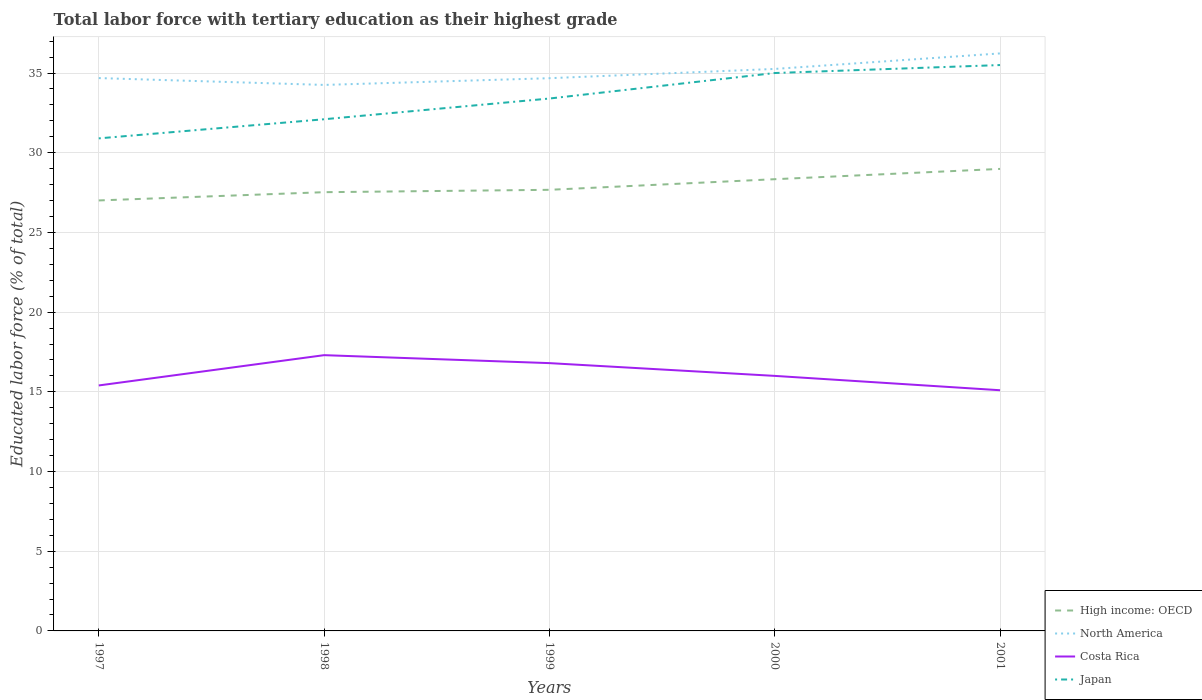Is the number of lines equal to the number of legend labels?
Your answer should be very brief. Yes. Across all years, what is the maximum percentage of male labor force with tertiary education in Costa Rica?
Ensure brevity in your answer.  15.1. What is the total percentage of male labor force with tertiary education in North America in the graph?
Your response must be concise. -1.55. What is the difference between the highest and the second highest percentage of male labor force with tertiary education in High income: OECD?
Give a very brief answer. 1.98. What is the difference between the highest and the lowest percentage of male labor force with tertiary education in High income: OECD?
Provide a short and direct response. 2. Does the graph contain grids?
Keep it short and to the point. Yes. Where does the legend appear in the graph?
Make the answer very short. Bottom right. How are the legend labels stacked?
Your answer should be very brief. Vertical. What is the title of the graph?
Your answer should be compact. Total labor force with tertiary education as their highest grade. What is the label or title of the Y-axis?
Provide a succinct answer. Educated labor force (% of total). What is the Educated labor force (% of total) in High income: OECD in 1997?
Keep it short and to the point. 27.01. What is the Educated labor force (% of total) in North America in 1997?
Keep it short and to the point. 34.68. What is the Educated labor force (% of total) of Costa Rica in 1997?
Provide a short and direct response. 15.4. What is the Educated labor force (% of total) of Japan in 1997?
Offer a very short reply. 30.9. What is the Educated labor force (% of total) in High income: OECD in 1998?
Give a very brief answer. 27.52. What is the Educated labor force (% of total) of North America in 1998?
Give a very brief answer. 34.25. What is the Educated labor force (% of total) of Costa Rica in 1998?
Offer a terse response. 17.3. What is the Educated labor force (% of total) in Japan in 1998?
Make the answer very short. 32.1. What is the Educated labor force (% of total) in High income: OECD in 1999?
Your response must be concise. 27.67. What is the Educated labor force (% of total) of North America in 1999?
Give a very brief answer. 34.68. What is the Educated labor force (% of total) in Costa Rica in 1999?
Keep it short and to the point. 16.8. What is the Educated labor force (% of total) of Japan in 1999?
Your response must be concise. 33.4. What is the Educated labor force (% of total) in High income: OECD in 2000?
Provide a short and direct response. 28.34. What is the Educated labor force (% of total) in North America in 2000?
Ensure brevity in your answer.  35.26. What is the Educated labor force (% of total) in Costa Rica in 2000?
Provide a succinct answer. 16. What is the Educated labor force (% of total) in High income: OECD in 2001?
Provide a short and direct response. 28.98. What is the Educated labor force (% of total) in North America in 2001?
Keep it short and to the point. 36.23. What is the Educated labor force (% of total) in Costa Rica in 2001?
Your response must be concise. 15.1. What is the Educated labor force (% of total) of Japan in 2001?
Provide a succinct answer. 35.5. Across all years, what is the maximum Educated labor force (% of total) in High income: OECD?
Make the answer very short. 28.98. Across all years, what is the maximum Educated labor force (% of total) in North America?
Offer a very short reply. 36.23. Across all years, what is the maximum Educated labor force (% of total) in Costa Rica?
Provide a short and direct response. 17.3. Across all years, what is the maximum Educated labor force (% of total) of Japan?
Provide a short and direct response. 35.5. Across all years, what is the minimum Educated labor force (% of total) in High income: OECD?
Keep it short and to the point. 27.01. Across all years, what is the minimum Educated labor force (% of total) of North America?
Ensure brevity in your answer.  34.25. Across all years, what is the minimum Educated labor force (% of total) in Costa Rica?
Ensure brevity in your answer.  15.1. Across all years, what is the minimum Educated labor force (% of total) of Japan?
Ensure brevity in your answer.  30.9. What is the total Educated labor force (% of total) of High income: OECD in the graph?
Make the answer very short. 139.53. What is the total Educated labor force (% of total) of North America in the graph?
Provide a short and direct response. 175.1. What is the total Educated labor force (% of total) of Costa Rica in the graph?
Your response must be concise. 80.6. What is the total Educated labor force (% of total) of Japan in the graph?
Your answer should be compact. 166.9. What is the difference between the Educated labor force (% of total) of High income: OECD in 1997 and that in 1998?
Provide a succinct answer. -0.52. What is the difference between the Educated labor force (% of total) in North America in 1997 and that in 1998?
Offer a very short reply. 0.43. What is the difference between the Educated labor force (% of total) of Costa Rica in 1997 and that in 1998?
Offer a terse response. -1.9. What is the difference between the Educated labor force (% of total) of Japan in 1997 and that in 1998?
Your answer should be compact. -1.2. What is the difference between the Educated labor force (% of total) of North America in 1997 and that in 1999?
Ensure brevity in your answer.  0.01. What is the difference between the Educated labor force (% of total) of Japan in 1997 and that in 1999?
Provide a short and direct response. -2.5. What is the difference between the Educated labor force (% of total) in High income: OECD in 1997 and that in 2000?
Offer a terse response. -1.33. What is the difference between the Educated labor force (% of total) of North America in 1997 and that in 2000?
Your answer should be compact. -0.57. What is the difference between the Educated labor force (% of total) in Costa Rica in 1997 and that in 2000?
Your answer should be compact. -0.6. What is the difference between the Educated labor force (% of total) in Japan in 1997 and that in 2000?
Your answer should be very brief. -4.1. What is the difference between the Educated labor force (% of total) in High income: OECD in 1997 and that in 2001?
Provide a succinct answer. -1.98. What is the difference between the Educated labor force (% of total) of North America in 1997 and that in 2001?
Your response must be concise. -1.55. What is the difference between the Educated labor force (% of total) in Japan in 1997 and that in 2001?
Your answer should be very brief. -4.6. What is the difference between the Educated labor force (% of total) in High income: OECD in 1998 and that in 1999?
Offer a terse response. -0.15. What is the difference between the Educated labor force (% of total) of North America in 1998 and that in 1999?
Keep it short and to the point. -0.42. What is the difference between the Educated labor force (% of total) in Costa Rica in 1998 and that in 1999?
Offer a very short reply. 0.5. What is the difference between the Educated labor force (% of total) in Japan in 1998 and that in 1999?
Make the answer very short. -1.3. What is the difference between the Educated labor force (% of total) of High income: OECD in 1998 and that in 2000?
Keep it short and to the point. -0.81. What is the difference between the Educated labor force (% of total) in North America in 1998 and that in 2000?
Your response must be concise. -1. What is the difference between the Educated labor force (% of total) of Costa Rica in 1998 and that in 2000?
Provide a succinct answer. 1.3. What is the difference between the Educated labor force (% of total) of Japan in 1998 and that in 2000?
Your response must be concise. -2.9. What is the difference between the Educated labor force (% of total) of High income: OECD in 1998 and that in 2001?
Your response must be concise. -1.46. What is the difference between the Educated labor force (% of total) of North America in 1998 and that in 2001?
Your answer should be very brief. -1.98. What is the difference between the Educated labor force (% of total) in High income: OECD in 1999 and that in 2000?
Give a very brief answer. -0.67. What is the difference between the Educated labor force (% of total) in North America in 1999 and that in 2000?
Make the answer very short. -0.58. What is the difference between the Educated labor force (% of total) of Costa Rica in 1999 and that in 2000?
Keep it short and to the point. 0.8. What is the difference between the Educated labor force (% of total) of High income: OECD in 1999 and that in 2001?
Provide a succinct answer. -1.31. What is the difference between the Educated labor force (% of total) in North America in 1999 and that in 2001?
Offer a very short reply. -1.55. What is the difference between the Educated labor force (% of total) of Costa Rica in 1999 and that in 2001?
Your response must be concise. 1.7. What is the difference between the Educated labor force (% of total) of High income: OECD in 2000 and that in 2001?
Your answer should be very brief. -0.65. What is the difference between the Educated labor force (% of total) of North America in 2000 and that in 2001?
Your answer should be very brief. -0.97. What is the difference between the Educated labor force (% of total) in High income: OECD in 1997 and the Educated labor force (% of total) in North America in 1998?
Your answer should be very brief. -7.25. What is the difference between the Educated labor force (% of total) of High income: OECD in 1997 and the Educated labor force (% of total) of Costa Rica in 1998?
Provide a succinct answer. 9.71. What is the difference between the Educated labor force (% of total) in High income: OECD in 1997 and the Educated labor force (% of total) in Japan in 1998?
Offer a terse response. -5.09. What is the difference between the Educated labor force (% of total) of North America in 1997 and the Educated labor force (% of total) of Costa Rica in 1998?
Provide a succinct answer. 17.38. What is the difference between the Educated labor force (% of total) in North America in 1997 and the Educated labor force (% of total) in Japan in 1998?
Your answer should be very brief. 2.58. What is the difference between the Educated labor force (% of total) in Costa Rica in 1997 and the Educated labor force (% of total) in Japan in 1998?
Make the answer very short. -16.7. What is the difference between the Educated labor force (% of total) of High income: OECD in 1997 and the Educated labor force (% of total) of North America in 1999?
Give a very brief answer. -7.67. What is the difference between the Educated labor force (% of total) of High income: OECD in 1997 and the Educated labor force (% of total) of Costa Rica in 1999?
Provide a succinct answer. 10.21. What is the difference between the Educated labor force (% of total) of High income: OECD in 1997 and the Educated labor force (% of total) of Japan in 1999?
Give a very brief answer. -6.39. What is the difference between the Educated labor force (% of total) in North America in 1997 and the Educated labor force (% of total) in Costa Rica in 1999?
Ensure brevity in your answer.  17.88. What is the difference between the Educated labor force (% of total) of North America in 1997 and the Educated labor force (% of total) of Japan in 1999?
Offer a terse response. 1.28. What is the difference between the Educated labor force (% of total) of High income: OECD in 1997 and the Educated labor force (% of total) of North America in 2000?
Offer a very short reply. -8.25. What is the difference between the Educated labor force (% of total) in High income: OECD in 1997 and the Educated labor force (% of total) in Costa Rica in 2000?
Your answer should be very brief. 11.01. What is the difference between the Educated labor force (% of total) of High income: OECD in 1997 and the Educated labor force (% of total) of Japan in 2000?
Offer a terse response. -7.99. What is the difference between the Educated labor force (% of total) of North America in 1997 and the Educated labor force (% of total) of Costa Rica in 2000?
Ensure brevity in your answer.  18.68. What is the difference between the Educated labor force (% of total) in North America in 1997 and the Educated labor force (% of total) in Japan in 2000?
Offer a terse response. -0.32. What is the difference between the Educated labor force (% of total) of Costa Rica in 1997 and the Educated labor force (% of total) of Japan in 2000?
Ensure brevity in your answer.  -19.6. What is the difference between the Educated labor force (% of total) in High income: OECD in 1997 and the Educated labor force (% of total) in North America in 2001?
Your answer should be compact. -9.22. What is the difference between the Educated labor force (% of total) of High income: OECD in 1997 and the Educated labor force (% of total) of Costa Rica in 2001?
Offer a very short reply. 11.91. What is the difference between the Educated labor force (% of total) of High income: OECD in 1997 and the Educated labor force (% of total) of Japan in 2001?
Offer a terse response. -8.49. What is the difference between the Educated labor force (% of total) in North America in 1997 and the Educated labor force (% of total) in Costa Rica in 2001?
Your answer should be very brief. 19.58. What is the difference between the Educated labor force (% of total) in North America in 1997 and the Educated labor force (% of total) in Japan in 2001?
Provide a short and direct response. -0.82. What is the difference between the Educated labor force (% of total) of Costa Rica in 1997 and the Educated labor force (% of total) of Japan in 2001?
Keep it short and to the point. -20.1. What is the difference between the Educated labor force (% of total) of High income: OECD in 1998 and the Educated labor force (% of total) of North America in 1999?
Your answer should be compact. -7.15. What is the difference between the Educated labor force (% of total) in High income: OECD in 1998 and the Educated labor force (% of total) in Costa Rica in 1999?
Provide a succinct answer. 10.72. What is the difference between the Educated labor force (% of total) in High income: OECD in 1998 and the Educated labor force (% of total) in Japan in 1999?
Your answer should be compact. -5.88. What is the difference between the Educated labor force (% of total) in North America in 1998 and the Educated labor force (% of total) in Costa Rica in 1999?
Give a very brief answer. 17.45. What is the difference between the Educated labor force (% of total) of North America in 1998 and the Educated labor force (% of total) of Japan in 1999?
Give a very brief answer. 0.85. What is the difference between the Educated labor force (% of total) in Costa Rica in 1998 and the Educated labor force (% of total) in Japan in 1999?
Your answer should be compact. -16.1. What is the difference between the Educated labor force (% of total) in High income: OECD in 1998 and the Educated labor force (% of total) in North America in 2000?
Keep it short and to the point. -7.73. What is the difference between the Educated labor force (% of total) of High income: OECD in 1998 and the Educated labor force (% of total) of Costa Rica in 2000?
Ensure brevity in your answer.  11.52. What is the difference between the Educated labor force (% of total) in High income: OECD in 1998 and the Educated labor force (% of total) in Japan in 2000?
Make the answer very short. -7.48. What is the difference between the Educated labor force (% of total) of North America in 1998 and the Educated labor force (% of total) of Costa Rica in 2000?
Your response must be concise. 18.25. What is the difference between the Educated labor force (% of total) in North America in 1998 and the Educated labor force (% of total) in Japan in 2000?
Give a very brief answer. -0.75. What is the difference between the Educated labor force (% of total) of Costa Rica in 1998 and the Educated labor force (% of total) of Japan in 2000?
Ensure brevity in your answer.  -17.7. What is the difference between the Educated labor force (% of total) in High income: OECD in 1998 and the Educated labor force (% of total) in North America in 2001?
Your response must be concise. -8.71. What is the difference between the Educated labor force (% of total) of High income: OECD in 1998 and the Educated labor force (% of total) of Costa Rica in 2001?
Your answer should be very brief. 12.42. What is the difference between the Educated labor force (% of total) of High income: OECD in 1998 and the Educated labor force (% of total) of Japan in 2001?
Give a very brief answer. -7.98. What is the difference between the Educated labor force (% of total) in North America in 1998 and the Educated labor force (% of total) in Costa Rica in 2001?
Your answer should be compact. 19.15. What is the difference between the Educated labor force (% of total) in North America in 1998 and the Educated labor force (% of total) in Japan in 2001?
Your answer should be compact. -1.25. What is the difference between the Educated labor force (% of total) of Costa Rica in 1998 and the Educated labor force (% of total) of Japan in 2001?
Make the answer very short. -18.2. What is the difference between the Educated labor force (% of total) of High income: OECD in 1999 and the Educated labor force (% of total) of North America in 2000?
Make the answer very short. -7.58. What is the difference between the Educated labor force (% of total) in High income: OECD in 1999 and the Educated labor force (% of total) in Costa Rica in 2000?
Keep it short and to the point. 11.67. What is the difference between the Educated labor force (% of total) in High income: OECD in 1999 and the Educated labor force (% of total) in Japan in 2000?
Offer a very short reply. -7.33. What is the difference between the Educated labor force (% of total) of North America in 1999 and the Educated labor force (% of total) of Costa Rica in 2000?
Keep it short and to the point. 18.68. What is the difference between the Educated labor force (% of total) in North America in 1999 and the Educated labor force (% of total) in Japan in 2000?
Your answer should be compact. -0.32. What is the difference between the Educated labor force (% of total) in Costa Rica in 1999 and the Educated labor force (% of total) in Japan in 2000?
Your answer should be compact. -18.2. What is the difference between the Educated labor force (% of total) of High income: OECD in 1999 and the Educated labor force (% of total) of North America in 2001?
Offer a terse response. -8.56. What is the difference between the Educated labor force (% of total) in High income: OECD in 1999 and the Educated labor force (% of total) in Costa Rica in 2001?
Your response must be concise. 12.57. What is the difference between the Educated labor force (% of total) of High income: OECD in 1999 and the Educated labor force (% of total) of Japan in 2001?
Your response must be concise. -7.83. What is the difference between the Educated labor force (% of total) of North America in 1999 and the Educated labor force (% of total) of Costa Rica in 2001?
Keep it short and to the point. 19.58. What is the difference between the Educated labor force (% of total) in North America in 1999 and the Educated labor force (% of total) in Japan in 2001?
Your response must be concise. -0.82. What is the difference between the Educated labor force (% of total) in Costa Rica in 1999 and the Educated labor force (% of total) in Japan in 2001?
Your answer should be very brief. -18.7. What is the difference between the Educated labor force (% of total) of High income: OECD in 2000 and the Educated labor force (% of total) of North America in 2001?
Make the answer very short. -7.89. What is the difference between the Educated labor force (% of total) in High income: OECD in 2000 and the Educated labor force (% of total) in Costa Rica in 2001?
Offer a very short reply. 13.24. What is the difference between the Educated labor force (% of total) in High income: OECD in 2000 and the Educated labor force (% of total) in Japan in 2001?
Your response must be concise. -7.16. What is the difference between the Educated labor force (% of total) in North America in 2000 and the Educated labor force (% of total) in Costa Rica in 2001?
Provide a short and direct response. 20.16. What is the difference between the Educated labor force (% of total) in North America in 2000 and the Educated labor force (% of total) in Japan in 2001?
Offer a terse response. -0.24. What is the difference between the Educated labor force (% of total) in Costa Rica in 2000 and the Educated labor force (% of total) in Japan in 2001?
Make the answer very short. -19.5. What is the average Educated labor force (% of total) of High income: OECD per year?
Give a very brief answer. 27.91. What is the average Educated labor force (% of total) of North America per year?
Keep it short and to the point. 35.02. What is the average Educated labor force (% of total) of Costa Rica per year?
Make the answer very short. 16.12. What is the average Educated labor force (% of total) of Japan per year?
Ensure brevity in your answer.  33.38. In the year 1997, what is the difference between the Educated labor force (% of total) in High income: OECD and Educated labor force (% of total) in North America?
Your response must be concise. -7.68. In the year 1997, what is the difference between the Educated labor force (% of total) in High income: OECD and Educated labor force (% of total) in Costa Rica?
Offer a terse response. 11.61. In the year 1997, what is the difference between the Educated labor force (% of total) in High income: OECD and Educated labor force (% of total) in Japan?
Keep it short and to the point. -3.89. In the year 1997, what is the difference between the Educated labor force (% of total) in North America and Educated labor force (% of total) in Costa Rica?
Keep it short and to the point. 19.28. In the year 1997, what is the difference between the Educated labor force (% of total) in North America and Educated labor force (% of total) in Japan?
Keep it short and to the point. 3.78. In the year 1997, what is the difference between the Educated labor force (% of total) of Costa Rica and Educated labor force (% of total) of Japan?
Keep it short and to the point. -15.5. In the year 1998, what is the difference between the Educated labor force (% of total) of High income: OECD and Educated labor force (% of total) of North America?
Your answer should be very brief. -6.73. In the year 1998, what is the difference between the Educated labor force (% of total) in High income: OECD and Educated labor force (% of total) in Costa Rica?
Your answer should be very brief. 10.22. In the year 1998, what is the difference between the Educated labor force (% of total) of High income: OECD and Educated labor force (% of total) of Japan?
Provide a short and direct response. -4.58. In the year 1998, what is the difference between the Educated labor force (% of total) in North America and Educated labor force (% of total) in Costa Rica?
Keep it short and to the point. 16.95. In the year 1998, what is the difference between the Educated labor force (% of total) in North America and Educated labor force (% of total) in Japan?
Provide a succinct answer. 2.15. In the year 1998, what is the difference between the Educated labor force (% of total) of Costa Rica and Educated labor force (% of total) of Japan?
Provide a short and direct response. -14.8. In the year 1999, what is the difference between the Educated labor force (% of total) of High income: OECD and Educated labor force (% of total) of North America?
Keep it short and to the point. -7. In the year 1999, what is the difference between the Educated labor force (% of total) in High income: OECD and Educated labor force (% of total) in Costa Rica?
Ensure brevity in your answer.  10.87. In the year 1999, what is the difference between the Educated labor force (% of total) in High income: OECD and Educated labor force (% of total) in Japan?
Your answer should be very brief. -5.73. In the year 1999, what is the difference between the Educated labor force (% of total) of North America and Educated labor force (% of total) of Costa Rica?
Ensure brevity in your answer.  17.88. In the year 1999, what is the difference between the Educated labor force (% of total) in North America and Educated labor force (% of total) in Japan?
Provide a succinct answer. 1.28. In the year 1999, what is the difference between the Educated labor force (% of total) in Costa Rica and Educated labor force (% of total) in Japan?
Make the answer very short. -16.6. In the year 2000, what is the difference between the Educated labor force (% of total) of High income: OECD and Educated labor force (% of total) of North America?
Ensure brevity in your answer.  -6.92. In the year 2000, what is the difference between the Educated labor force (% of total) in High income: OECD and Educated labor force (% of total) in Costa Rica?
Make the answer very short. 12.34. In the year 2000, what is the difference between the Educated labor force (% of total) of High income: OECD and Educated labor force (% of total) of Japan?
Provide a succinct answer. -6.66. In the year 2000, what is the difference between the Educated labor force (% of total) of North America and Educated labor force (% of total) of Costa Rica?
Provide a succinct answer. 19.26. In the year 2000, what is the difference between the Educated labor force (% of total) of North America and Educated labor force (% of total) of Japan?
Provide a succinct answer. 0.26. In the year 2001, what is the difference between the Educated labor force (% of total) in High income: OECD and Educated labor force (% of total) in North America?
Make the answer very short. -7.25. In the year 2001, what is the difference between the Educated labor force (% of total) of High income: OECD and Educated labor force (% of total) of Costa Rica?
Offer a terse response. 13.88. In the year 2001, what is the difference between the Educated labor force (% of total) in High income: OECD and Educated labor force (% of total) in Japan?
Offer a terse response. -6.52. In the year 2001, what is the difference between the Educated labor force (% of total) in North America and Educated labor force (% of total) in Costa Rica?
Your answer should be compact. 21.13. In the year 2001, what is the difference between the Educated labor force (% of total) in North America and Educated labor force (% of total) in Japan?
Your answer should be compact. 0.73. In the year 2001, what is the difference between the Educated labor force (% of total) in Costa Rica and Educated labor force (% of total) in Japan?
Your response must be concise. -20.4. What is the ratio of the Educated labor force (% of total) in High income: OECD in 1997 to that in 1998?
Offer a very short reply. 0.98. What is the ratio of the Educated labor force (% of total) of North America in 1997 to that in 1998?
Your answer should be very brief. 1.01. What is the ratio of the Educated labor force (% of total) of Costa Rica in 1997 to that in 1998?
Provide a succinct answer. 0.89. What is the ratio of the Educated labor force (% of total) in Japan in 1997 to that in 1998?
Offer a very short reply. 0.96. What is the ratio of the Educated labor force (% of total) of High income: OECD in 1997 to that in 1999?
Your response must be concise. 0.98. What is the ratio of the Educated labor force (% of total) in Costa Rica in 1997 to that in 1999?
Ensure brevity in your answer.  0.92. What is the ratio of the Educated labor force (% of total) of Japan in 1997 to that in 1999?
Your response must be concise. 0.93. What is the ratio of the Educated labor force (% of total) in High income: OECD in 1997 to that in 2000?
Ensure brevity in your answer.  0.95. What is the ratio of the Educated labor force (% of total) in North America in 1997 to that in 2000?
Your answer should be very brief. 0.98. What is the ratio of the Educated labor force (% of total) in Costa Rica in 1997 to that in 2000?
Your response must be concise. 0.96. What is the ratio of the Educated labor force (% of total) of Japan in 1997 to that in 2000?
Offer a very short reply. 0.88. What is the ratio of the Educated labor force (% of total) in High income: OECD in 1997 to that in 2001?
Ensure brevity in your answer.  0.93. What is the ratio of the Educated labor force (% of total) in North America in 1997 to that in 2001?
Your answer should be very brief. 0.96. What is the ratio of the Educated labor force (% of total) in Costa Rica in 1997 to that in 2001?
Give a very brief answer. 1.02. What is the ratio of the Educated labor force (% of total) in Japan in 1997 to that in 2001?
Give a very brief answer. 0.87. What is the ratio of the Educated labor force (% of total) in High income: OECD in 1998 to that in 1999?
Provide a succinct answer. 0.99. What is the ratio of the Educated labor force (% of total) of Costa Rica in 1998 to that in 1999?
Provide a succinct answer. 1.03. What is the ratio of the Educated labor force (% of total) of Japan in 1998 to that in 1999?
Offer a very short reply. 0.96. What is the ratio of the Educated labor force (% of total) of High income: OECD in 1998 to that in 2000?
Your answer should be very brief. 0.97. What is the ratio of the Educated labor force (% of total) in North America in 1998 to that in 2000?
Make the answer very short. 0.97. What is the ratio of the Educated labor force (% of total) of Costa Rica in 1998 to that in 2000?
Your answer should be compact. 1.08. What is the ratio of the Educated labor force (% of total) in Japan in 1998 to that in 2000?
Give a very brief answer. 0.92. What is the ratio of the Educated labor force (% of total) in High income: OECD in 1998 to that in 2001?
Keep it short and to the point. 0.95. What is the ratio of the Educated labor force (% of total) in North America in 1998 to that in 2001?
Keep it short and to the point. 0.95. What is the ratio of the Educated labor force (% of total) of Costa Rica in 1998 to that in 2001?
Keep it short and to the point. 1.15. What is the ratio of the Educated labor force (% of total) in Japan in 1998 to that in 2001?
Provide a succinct answer. 0.9. What is the ratio of the Educated labor force (% of total) of High income: OECD in 1999 to that in 2000?
Offer a terse response. 0.98. What is the ratio of the Educated labor force (% of total) of North America in 1999 to that in 2000?
Provide a short and direct response. 0.98. What is the ratio of the Educated labor force (% of total) in Japan in 1999 to that in 2000?
Your answer should be compact. 0.95. What is the ratio of the Educated labor force (% of total) of High income: OECD in 1999 to that in 2001?
Your response must be concise. 0.95. What is the ratio of the Educated labor force (% of total) of North America in 1999 to that in 2001?
Keep it short and to the point. 0.96. What is the ratio of the Educated labor force (% of total) of Costa Rica in 1999 to that in 2001?
Ensure brevity in your answer.  1.11. What is the ratio of the Educated labor force (% of total) in Japan in 1999 to that in 2001?
Make the answer very short. 0.94. What is the ratio of the Educated labor force (% of total) in High income: OECD in 2000 to that in 2001?
Your answer should be very brief. 0.98. What is the ratio of the Educated labor force (% of total) of North America in 2000 to that in 2001?
Make the answer very short. 0.97. What is the ratio of the Educated labor force (% of total) in Costa Rica in 2000 to that in 2001?
Make the answer very short. 1.06. What is the ratio of the Educated labor force (% of total) of Japan in 2000 to that in 2001?
Make the answer very short. 0.99. What is the difference between the highest and the second highest Educated labor force (% of total) in High income: OECD?
Give a very brief answer. 0.65. What is the difference between the highest and the second highest Educated labor force (% of total) in North America?
Offer a terse response. 0.97. What is the difference between the highest and the second highest Educated labor force (% of total) in Costa Rica?
Your answer should be very brief. 0.5. What is the difference between the highest and the lowest Educated labor force (% of total) of High income: OECD?
Your response must be concise. 1.98. What is the difference between the highest and the lowest Educated labor force (% of total) of North America?
Make the answer very short. 1.98. What is the difference between the highest and the lowest Educated labor force (% of total) of Costa Rica?
Your answer should be compact. 2.2. 